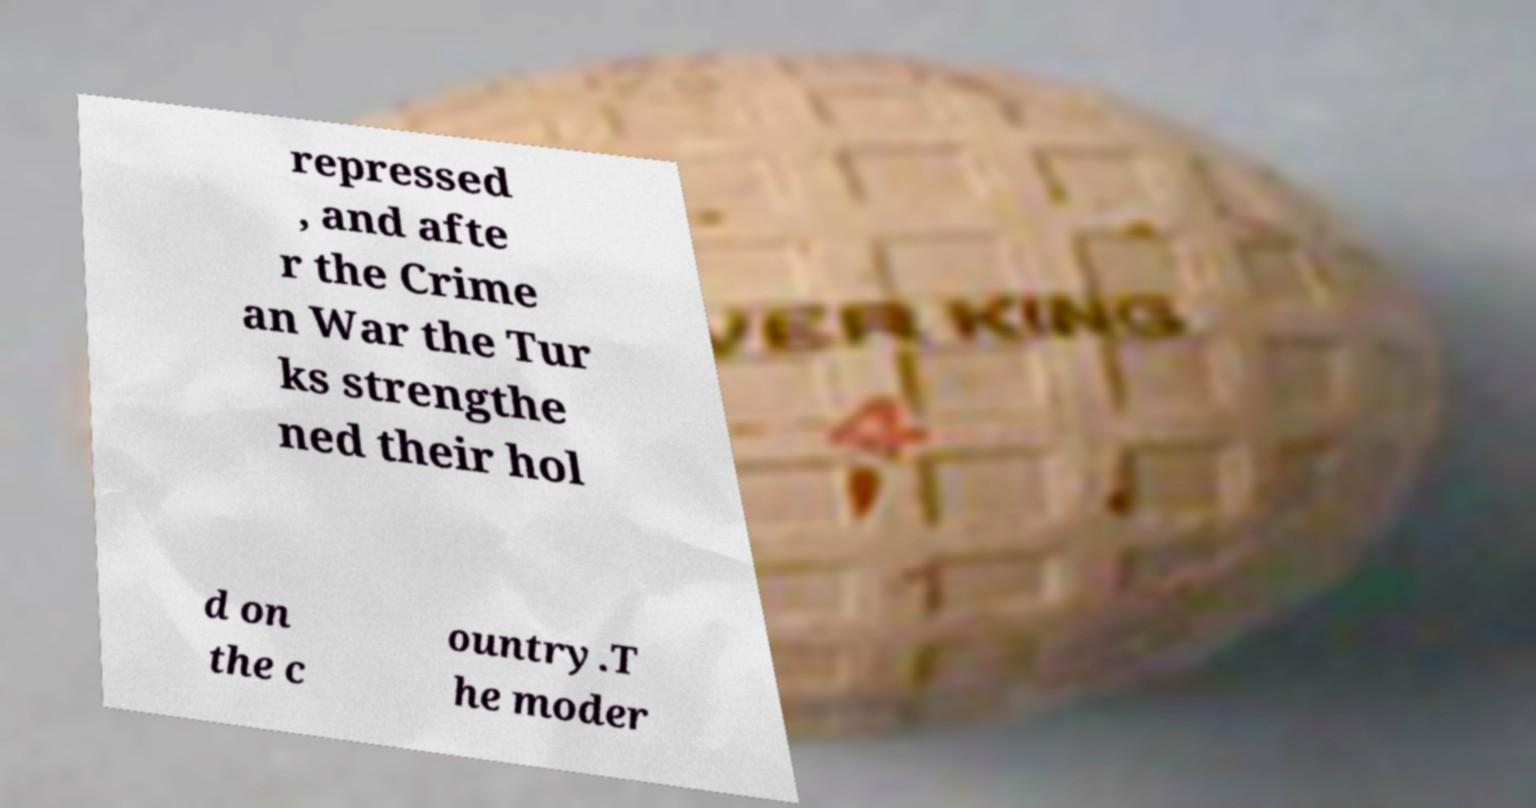I need the written content from this picture converted into text. Can you do that? repressed , and afte r the Crime an War the Tur ks strengthe ned their hol d on the c ountry.T he moder 